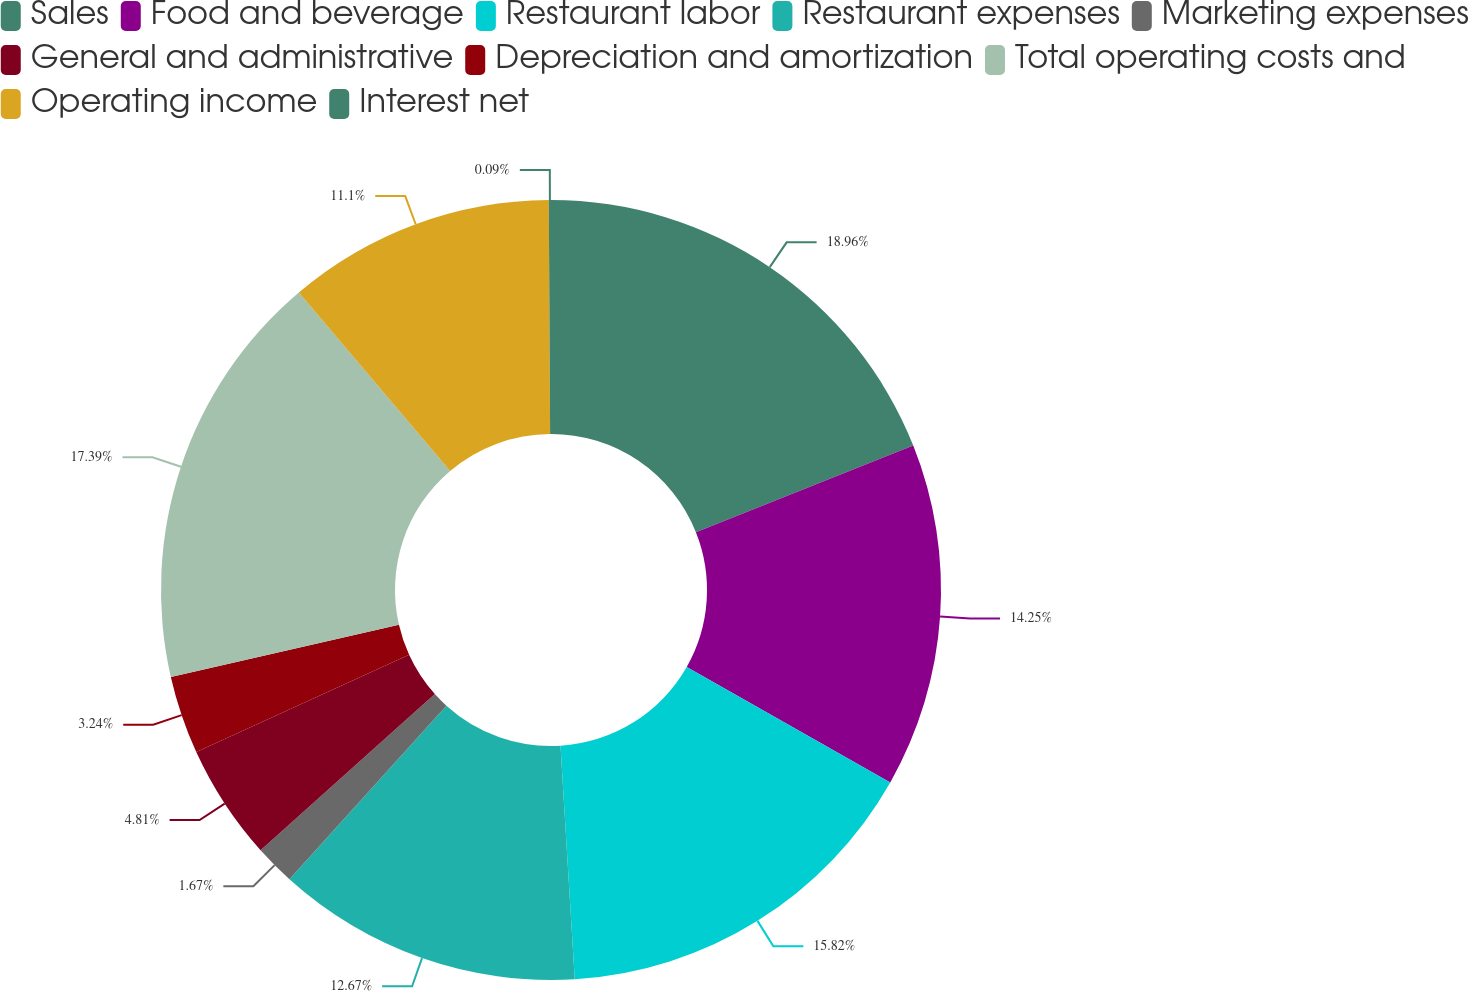<chart> <loc_0><loc_0><loc_500><loc_500><pie_chart><fcel>Sales<fcel>Food and beverage<fcel>Restaurant labor<fcel>Restaurant expenses<fcel>Marketing expenses<fcel>General and administrative<fcel>Depreciation and amortization<fcel>Total operating costs and<fcel>Operating income<fcel>Interest net<nl><fcel>18.96%<fcel>14.25%<fcel>15.82%<fcel>12.67%<fcel>1.67%<fcel>4.81%<fcel>3.24%<fcel>17.39%<fcel>11.1%<fcel>0.09%<nl></chart> 